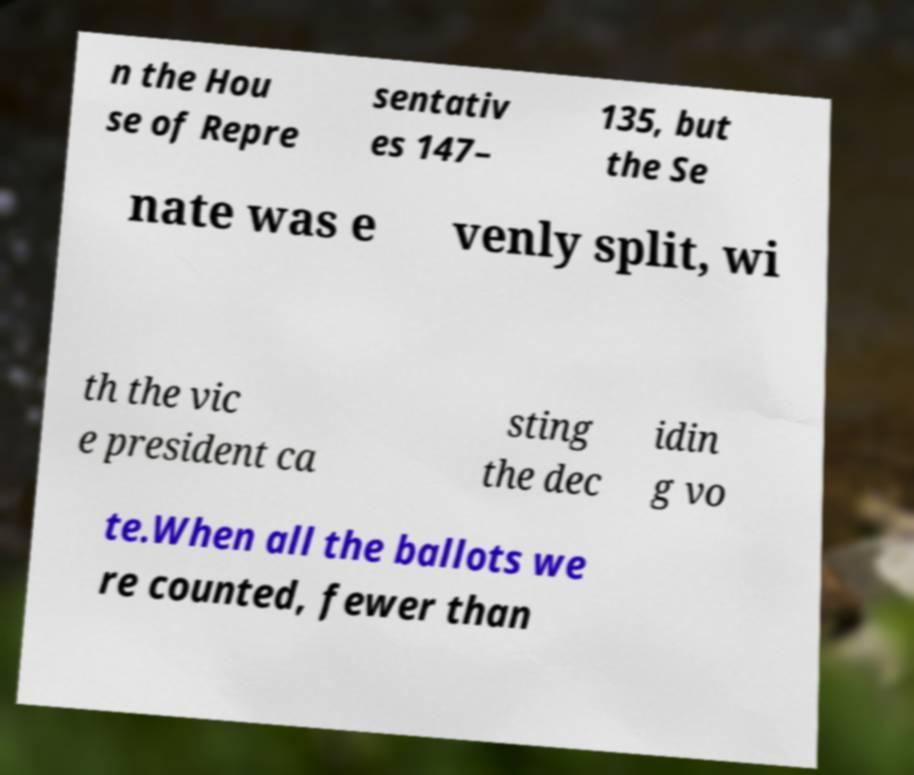Could you assist in decoding the text presented in this image and type it out clearly? n the Hou se of Repre sentativ es 147– 135, but the Se nate was e venly split, wi th the vic e president ca sting the dec idin g vo te.When all the ballots we re counted, fewer than 